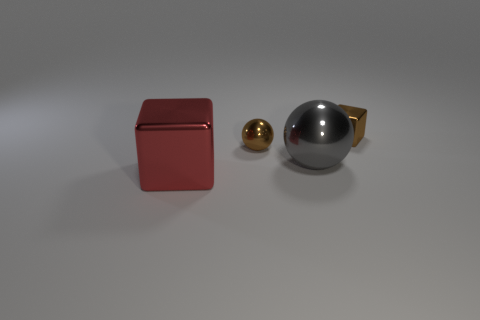Add 1 small brown metal things. How many objects exist? 5 Subtract 1 balls. How many balls are left? 1 Add 3 tiny metal cubes. How many tiny metal cubes exist? 4 Subtract 0 brown cylinders. How many objects are left? 4 Subtract all purple balls. Subtract all blue cubes. How many balls are left? 2 Subtract all blue blocks. How many brown balls are left? 1 Subtract all small purple matte spheres. Subtract all gray shiny things. How many objects are left? 3 Add 4 big red metal cubes. How many big red metal cubes are left? 5 